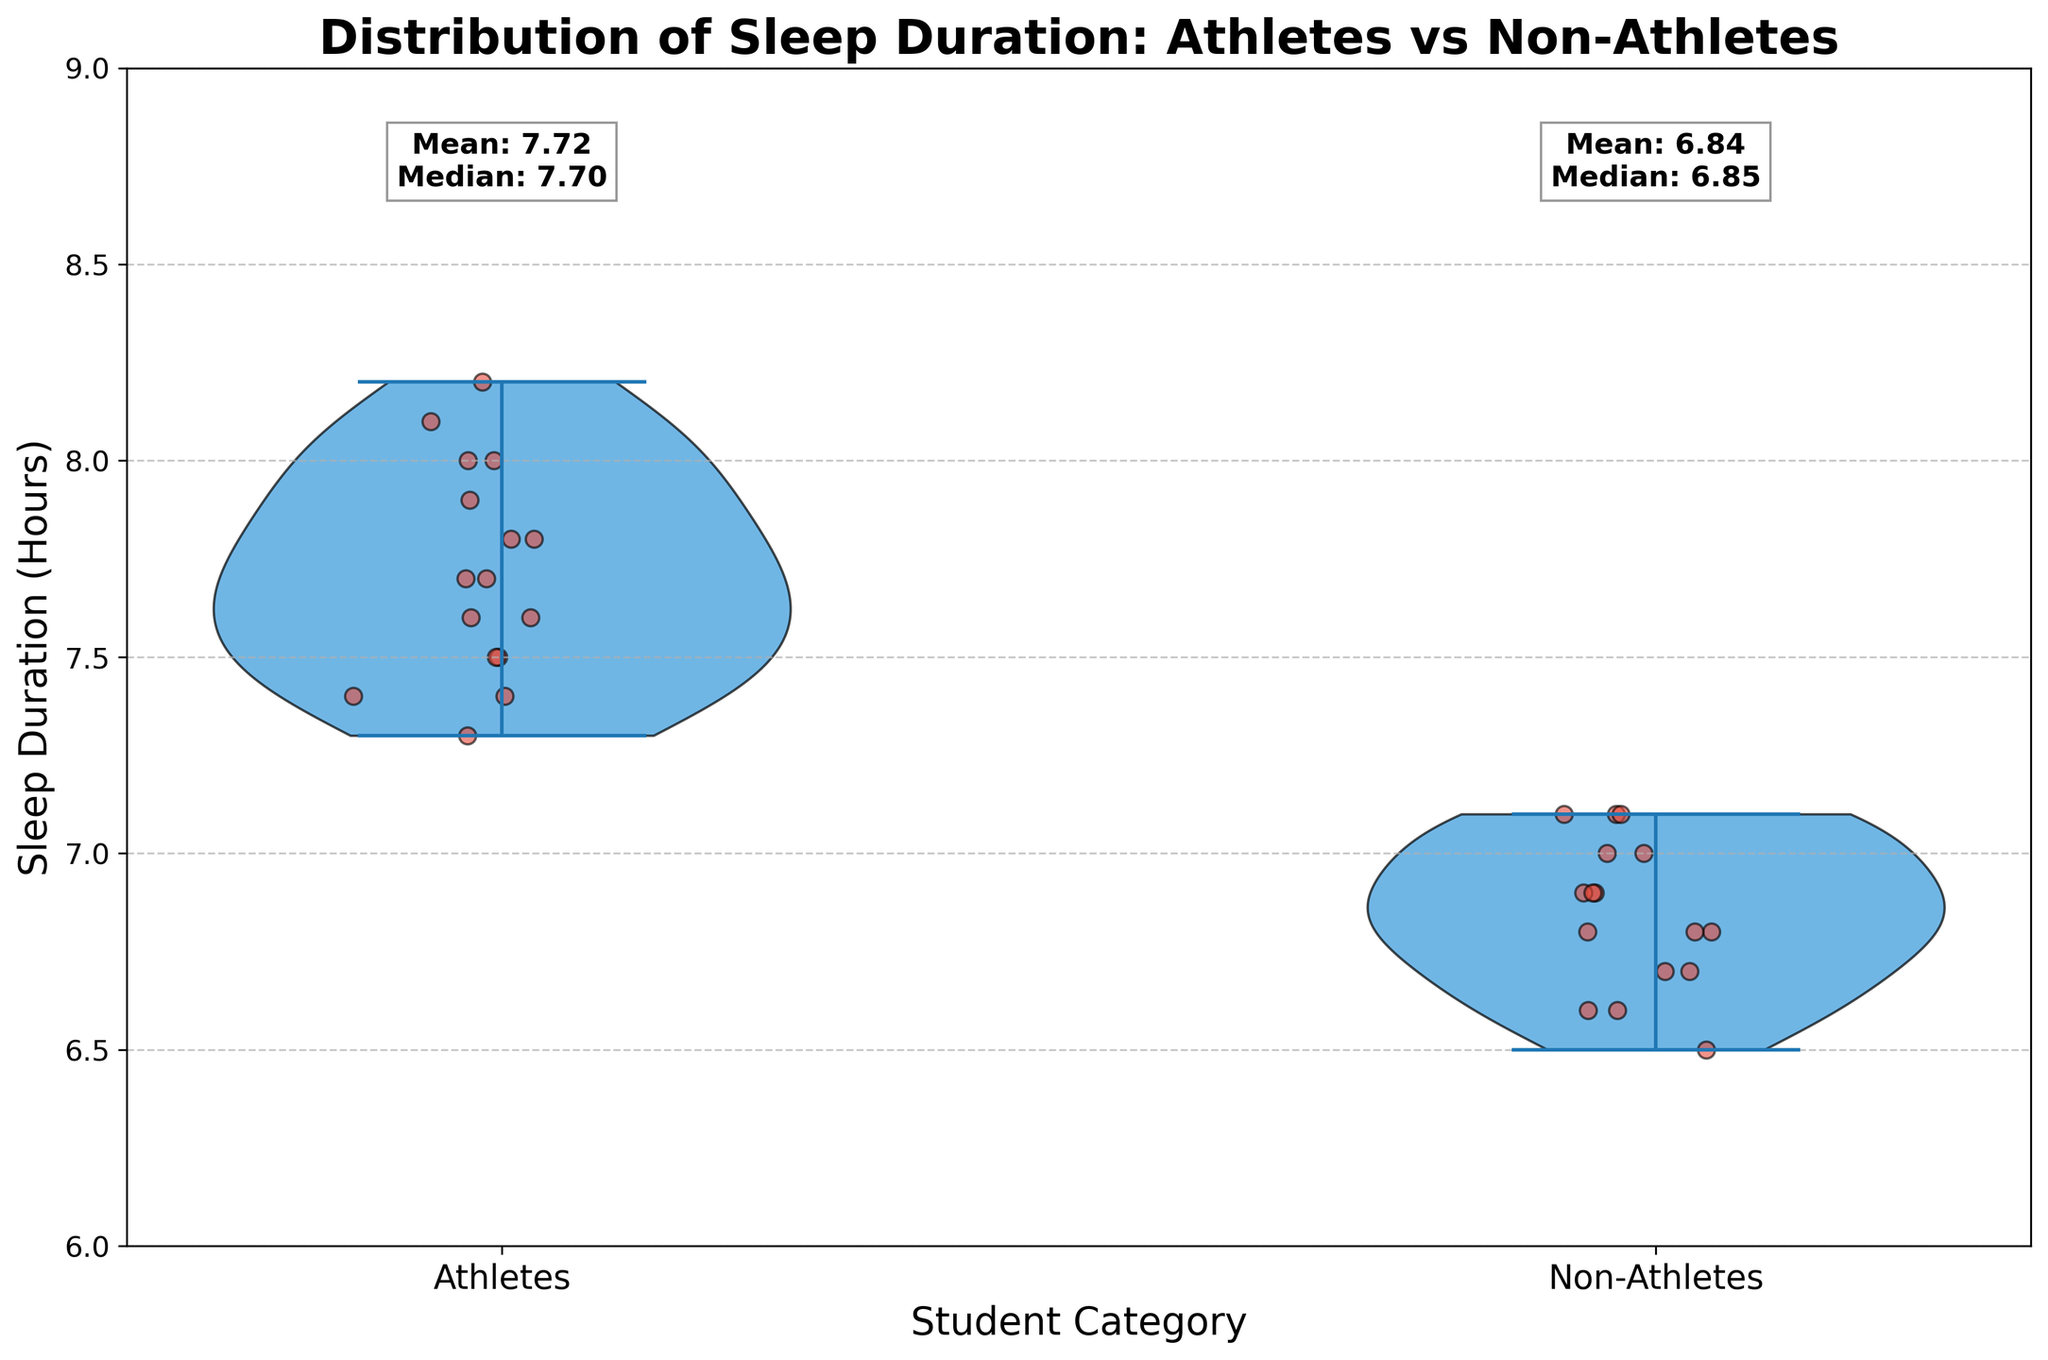What's the title of the chart? The chart's title is usually placed at the top of the figure in a bold, large font.
Answer: Distribution of Sleep Duration: Athletes vs Non-Athletes What are the labels on the x-axis? The x-axis labels are typically found under the horizontal line and are meant to identify the categories being compared.
Answer: Athletes, Non-Athletes What is the average sleep duration for athletes? The average sleep duration for athletes is noted directly on the chart above the violin plot for athletes, displayed in a text box.
Answer: 7.73 What is the average sleep duration for non-athletes? The average sleep duration for non-athletes is provided above the violin plot for non-athletes, displayed in a text box.
Answer: 6.84 Which category shows a higher median sleep duration, athletes or non-athletes? Median values are given in the same text box above each violin plot, indicating the central tendency of sleep duration for each group.
Answer: Athletes How do the jittered points help in understanding the data? Jittered points overlaid on the violin plot show individual data points, making it easier to observe the spread and exact values of data within each category.
Answer: They show individual data points and spread Which group has a wider range of sleep duration? The width of the violin plot and the spread of the jittered points indicate the range; a broader spread suggests a wider range.
Answer: Athletes Are the more substantial sleeper outliers athletes or non-athletes? Outliers, if present, will appear as far-removed points from the main body of the violin plot. The jittered points help identify if there are exceptionally high or low values.
Answer: Athletes What is the minimum sleep duration for non-athletes? Observing the lowest point in the violin plot or the lowest jittered point for non-athletes will give this information.
Answer: 6.5 Comparing means and medians, is the data for athletes more skewed or non-athletes? By comparing the differences between the mean and median from the text boxes above each violin plot, it's possible to infer the skewness. Larger differences indicate more skew.
Answer: Non-athletes 